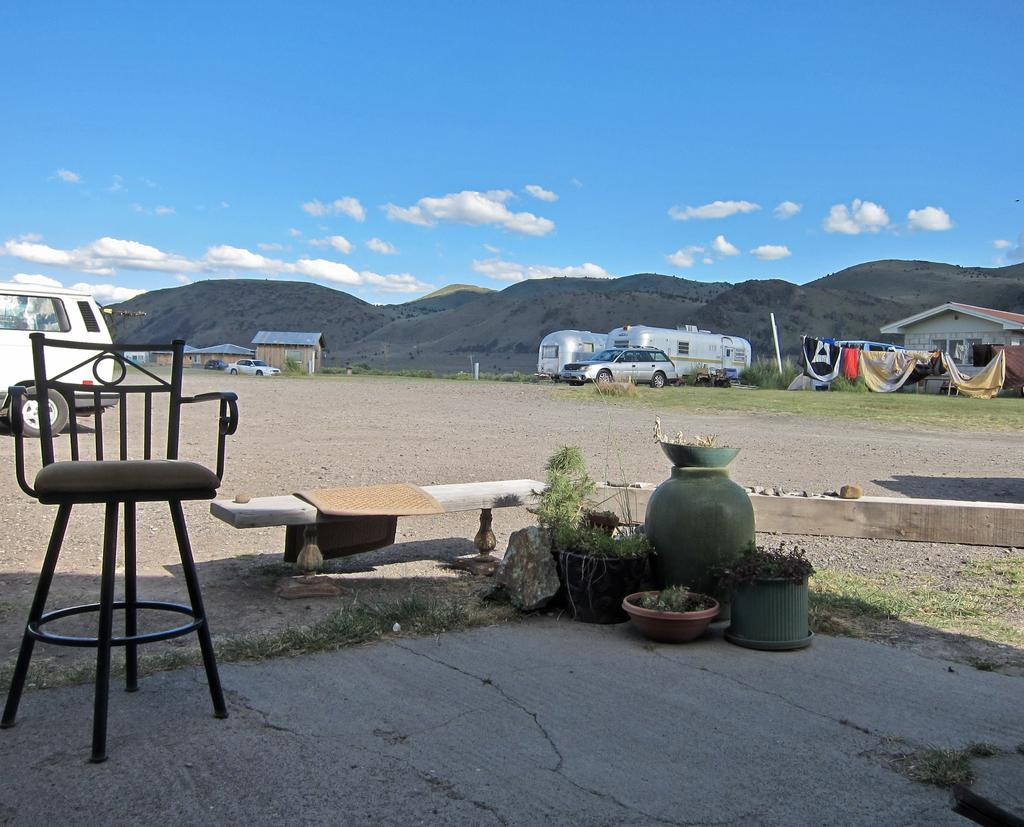What is the color and condition of the sky in the image? The sky in the image is blue and cloudy. What type of work environment is depicted in the image? There are cubicles in the open space, suggesting an office setting. What type of building can be seen in the image? A house is visible in the image. What type of furniture is present in the image? There is a chair in the image. What type of greenery is present in the image? There are plants in the image. What type of rake is being used by the spy in the image? There is no spy or rake present in the image. What route is the person taking to reach the house in the image? The image does not show a person or a route to the house; it only shows the house itself. 